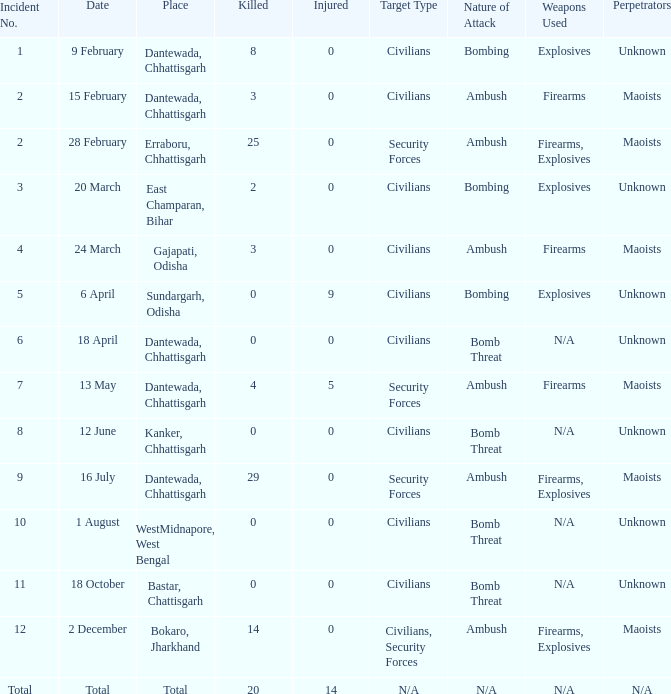How many people were injured in total in East Champaran, Bihar with more than 2 people killed? 0.0. 